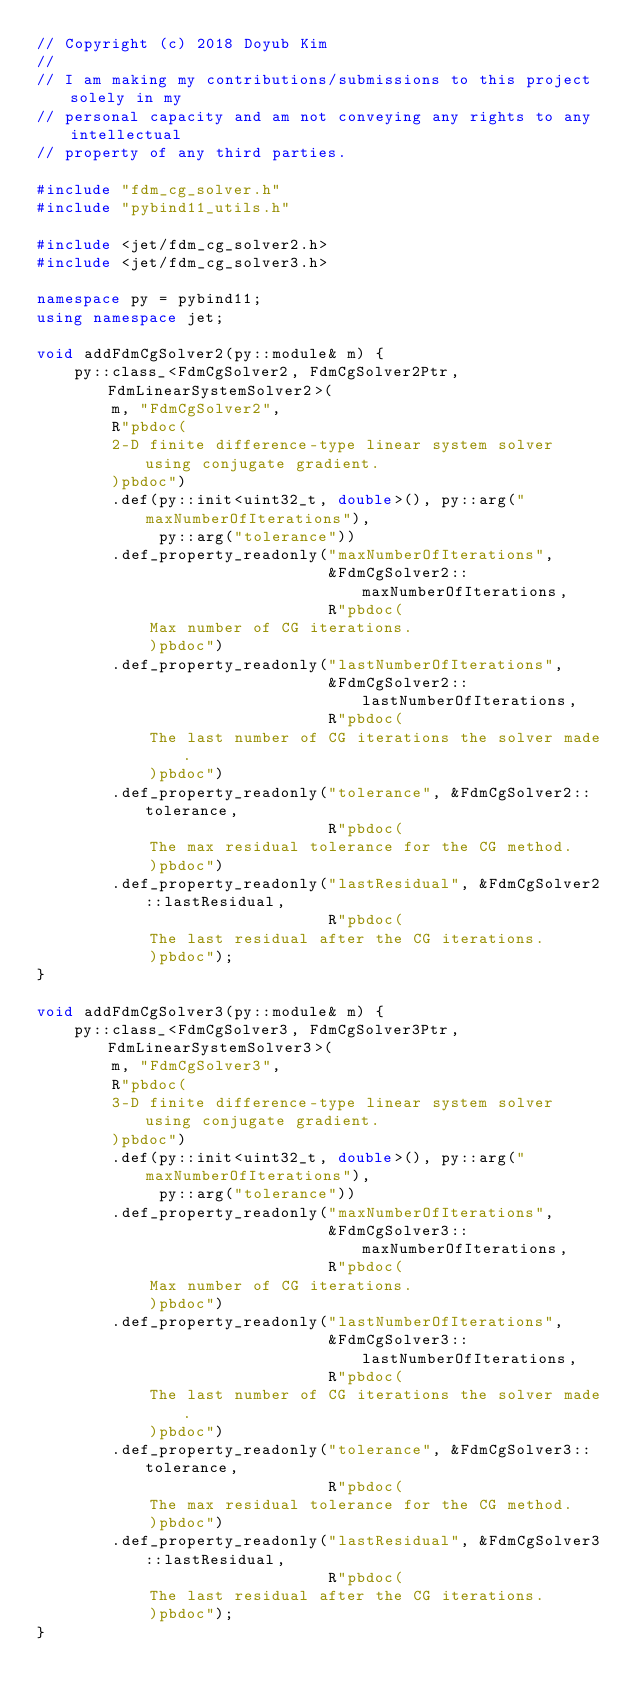<code> <loc_0><loc_0><loc_500><loc_500><_C++_>// Copyright (c) 2018 Doyub Kim
//
// I am making my contributions/submissions to this project solely in my
// personal capacity and am not conveying any rights to any intellectual
// property of any third parties.

#include "fdm_cg_solver.h"
#include "pybind11_utils.h"

#include <jet/fdm_cg_solver2.h>
#include <jet/fdm_cg_solver3.h>

namespace py = pybind11;
using namespace jet;

void addFdmCgSolver2(py::module& m) {
    py::class_<FdmCgSolver2, FdmCgSolver2Ptr, FdmLinearSystemSolver2>(
        m, "FdmCgSolver2",
        R"pbdoc(
        2-D finite difference-type linear system solver using conjugate gradient.
        )pbdoc")
        .def(py::init<uint32_t, double>(), py::arg("maxNumberOfIterations"),
             py::arg("tolerance"))
        .def_property_readonly("maxNumberOfIterations",
                               &FdmCgSolver2::maxNumberOfIterations,
                               R"pbdoc(
            Max number of CG iterations.
            )pbdoc")
        .def_property_readonly("lastNumberOfIterations",
                               &FdmCgSolver2::lastNumberOfIterations,
                               R"pbdoc(
            The last number of CG iterations the solver made.
            )pbdoc")
        .def_property_readonly("tolerance", &FdmCgSolver2::tolerance,
                               R"pbdoc(
            The max residual tolerance for the CG method.
            )pbdoc")
        .def_property_readonly("lastResidual", &FdmCgSolver2::lastResidual,
                               R"pbdoc(
            The last residual after the CG iterations.
            )pbdoc");
}

void addFdmCgSolver3(py::module& m) {
    py::class_<FdmCgSolver3, FdmCgSolver3Ptr, FdmLinearSystemSolver3>(
        m, "FdmCgSolver3",
        R"pbdoc(
        3-D finite difference-type linear system solver using conjugate gradient.
        )pbdoc")
        .def(py::init<uint32_t, double>(), py::arg("maxNumberOfIterations"),
             py::arg("tolerance"))
        .def_property_readonly("maxNumberOfIterations",
                               &FdmCgSolver3::maxNumberOfIterations,
                               R"pbdoc(
            Max number of CG iterations.
            )pbdoc")
        .def_property_readonly("lastNumberOfIterations",
                               &FdmCgSolver3::lastNumberOfIterations,
                               R"pbdoc(
            The last number of CG iterations the solver made.
            )pbdoc")
        .def_property_readonly("tolerance", &FdmCgSolver3::tolerance,
                               R"pbdoc(
            The max residual tolerance for the CG method.
            )pbdoc")
        .def_property_readonly("lastResidual", &FdmCgSolver3::lastResidual,
                               R"pbdoc(
            The last residual after the CG iterations.
            )pbdoc");
}
</code> 